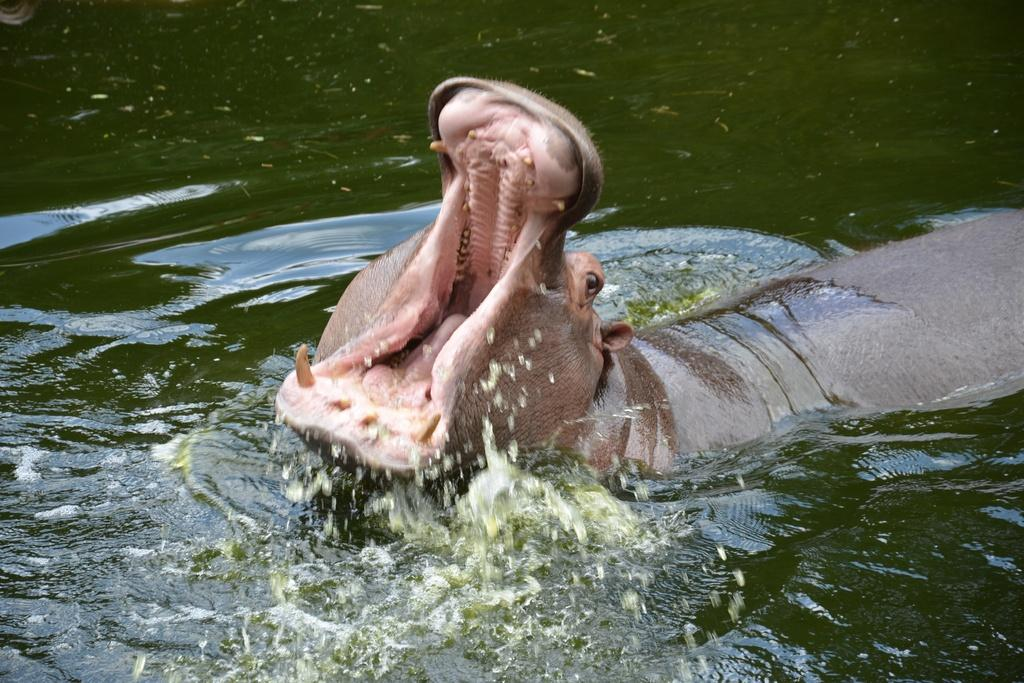What is the main subject in the center of the image? There is an animal in the center of the image. What can be seen at the bottom of the image? There is water at the bottom of the image. What type of pet is sitting on the monkey's shoulder in the image? There is no pet or monkey present in the image. 